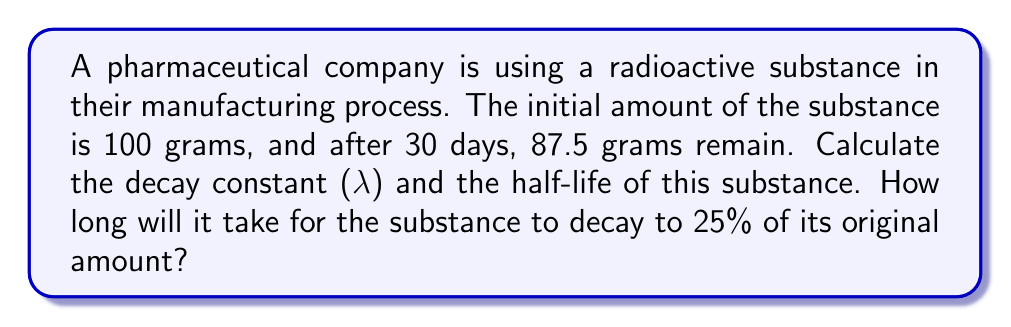Give your solution to this math problem. 1. First, let's calculate the decay constant (λ) using the exponential decay formula:

   $N(t) = N_0 e^{-λt}$

   Where $N(t)$ is the amount at time $t$, $N_0$ is the initial amount, and $t$ is time.

2. Plugging in our values:
   $87.5 = 100 e^{-λ(30)}$

3. Dividing both sides by 100:
   $0.875 = e^{-30λ}$

4. Taking the natural log of both sides:
   $\ln(0.875) = -30λ$

5. Solving for λ:
   $λ = -\frac{\ln(0.875)}{30} \approx 0.00444 \text{ day}^{-1}$

6. To calculate the half-life ($t_{1/2}$), we use:
   $t_{1/2} = \frac{\ln(2)}{λ} = \frac{0.693}{0.00444} \approx 156.1 \text{ days}$

7. To find the time for the substance to decay to 25% of its original amount:
   $0.25 = e^{-λt}$

8. Taking the natural log of both sides:
   $\ln(0.25) = -λt$

9. Solving for $t$:
   $t = -\frac{\ln(0.25)}{λ} = \frac{1.386}{0.00444} \approx 312.2 \text{ days}$
Answer: $λ \approx 0.00444 \text{ day}^{-1}$; $t_{1/2} \approx 156.1 \text{ days}$; $312.2 \text{ days}$ to reach 25% 